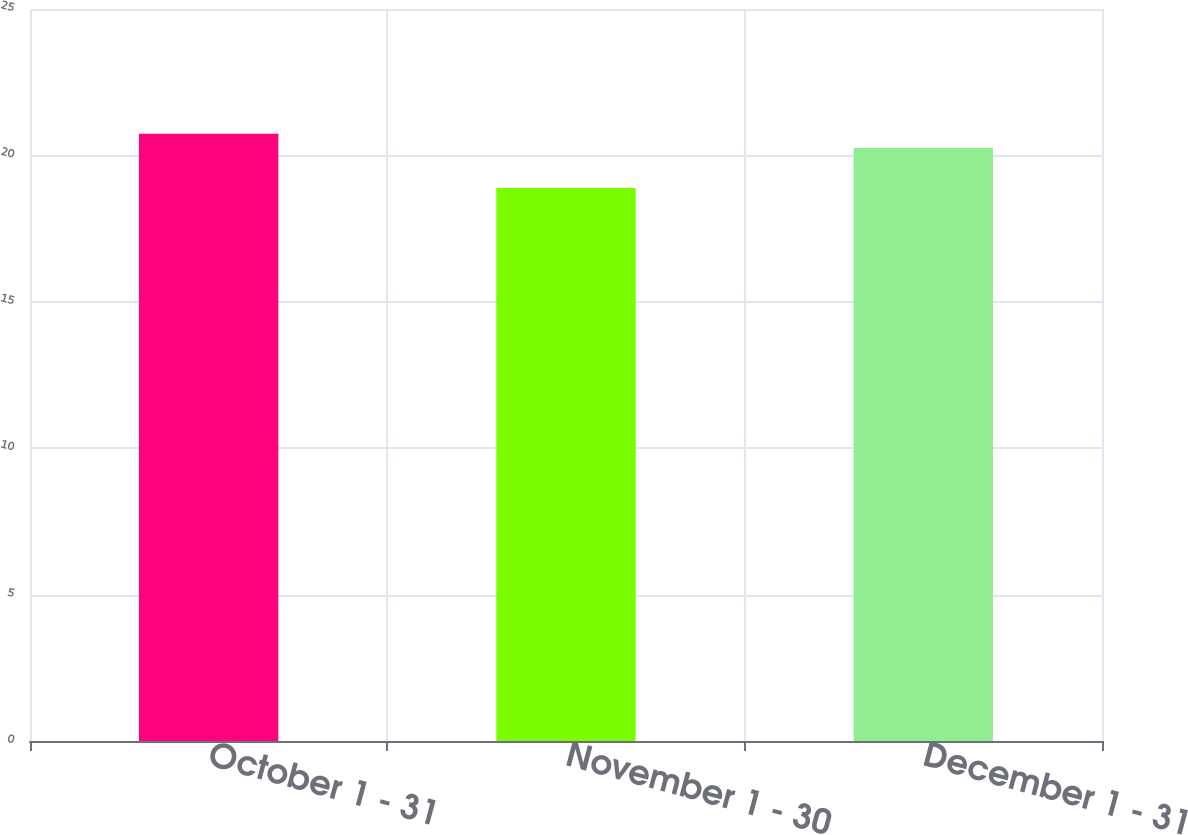<chart> <loc_0><loc_0><loc_500><loc_500><bar_chart><fcel>October 1 - 31<fcel>November 1 - 30<fcel>December 1 - 31<nl><fcel>20.74<fcel>18.89<fcel>20.25<nl></chart> 